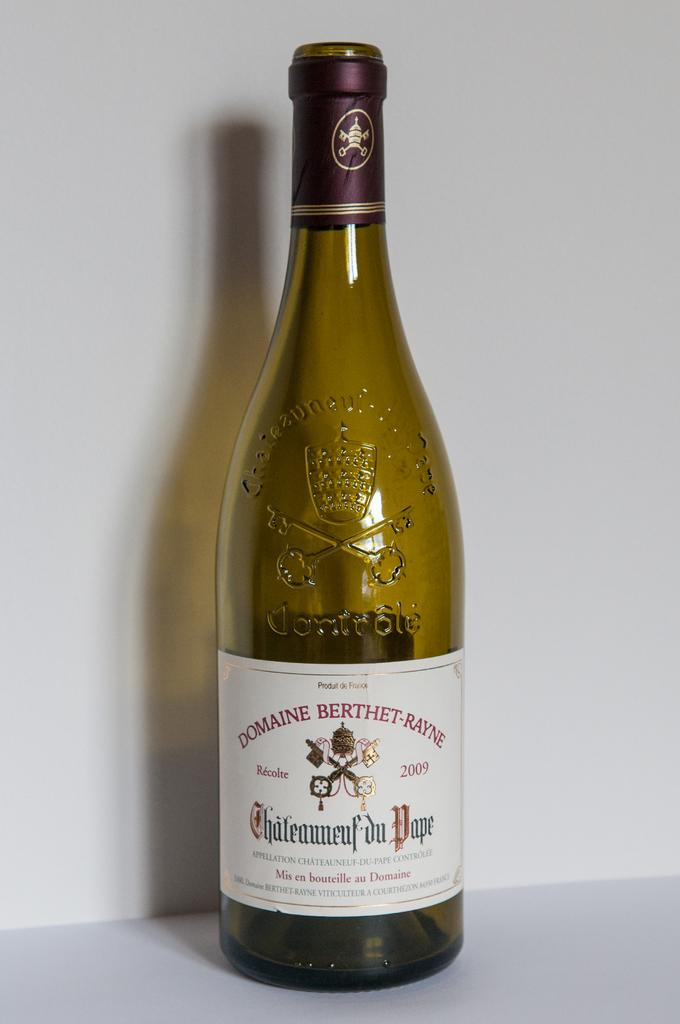What object can be seen in the image? There is a bottle in the image. What is on the bottle? The bottle has a sticker on it. Where is the bottle located? The bottle is placed on a white floor. What type of suit is the bottle wearing in the image? The bottle is not wearing a suit, as it is an inanimate object and does not have the ability to wear clothing. 